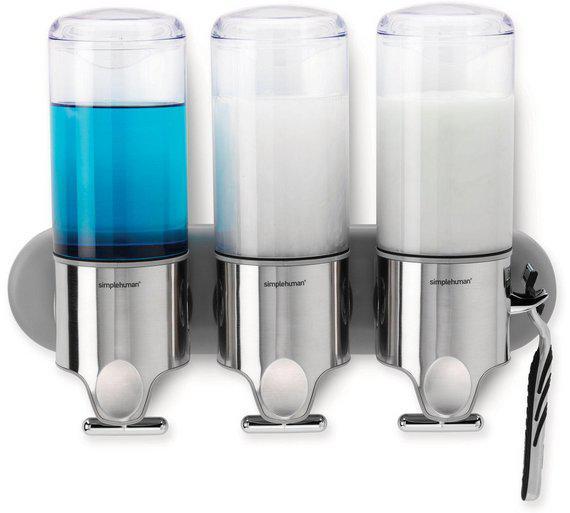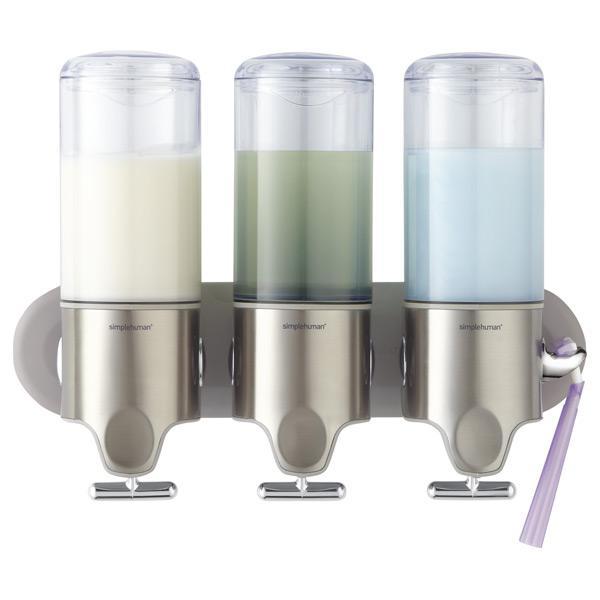The first image is the image on the left, the second image is the image on the right. Assess this claim about the two images: "There are three dispensers filled with substances in each of the images.". Correct or not? Answer yes or no. Yes. The first image is the image on the left, the second image is the image on the right. Examine the images to the left and right. Is the description "Each image shows three side-by-side dispensers, with at least one containing a bluish substance." accurate? Answer yes or no. Yes. 